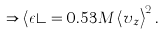Convert formula to latex. <formula><loc_0><loc_0><loc_500><loc_500>\Rightarrow \left < \epsilon \right > = 0 . 5 3 M \left < v _ { z } \right > ^ { 2 } .</formula> 